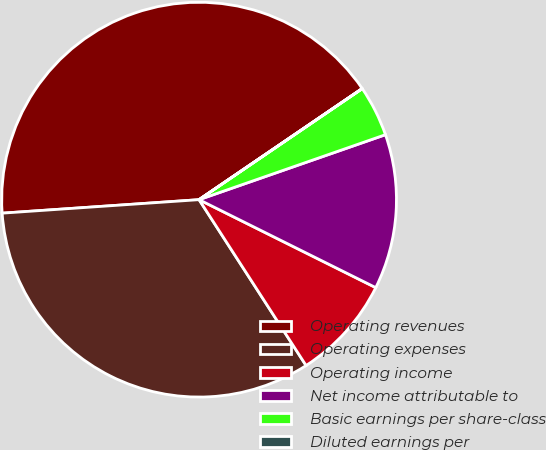<chart> <loc_0><loc_0><loc_500><loc_500><pie_chart><fcel>Operating revenues<fcel>Operating expenses<fcel>Operating income<fcel>Net income attributable to<fcel>Basic earnings per share-class<fcel>Diluted earnings per<nl><fcel>41.57%<fcel>33.03%<fcel>8.53%<fcel>12.69%<fcel>4.17%<fcel>0.01%<nl></chart> 